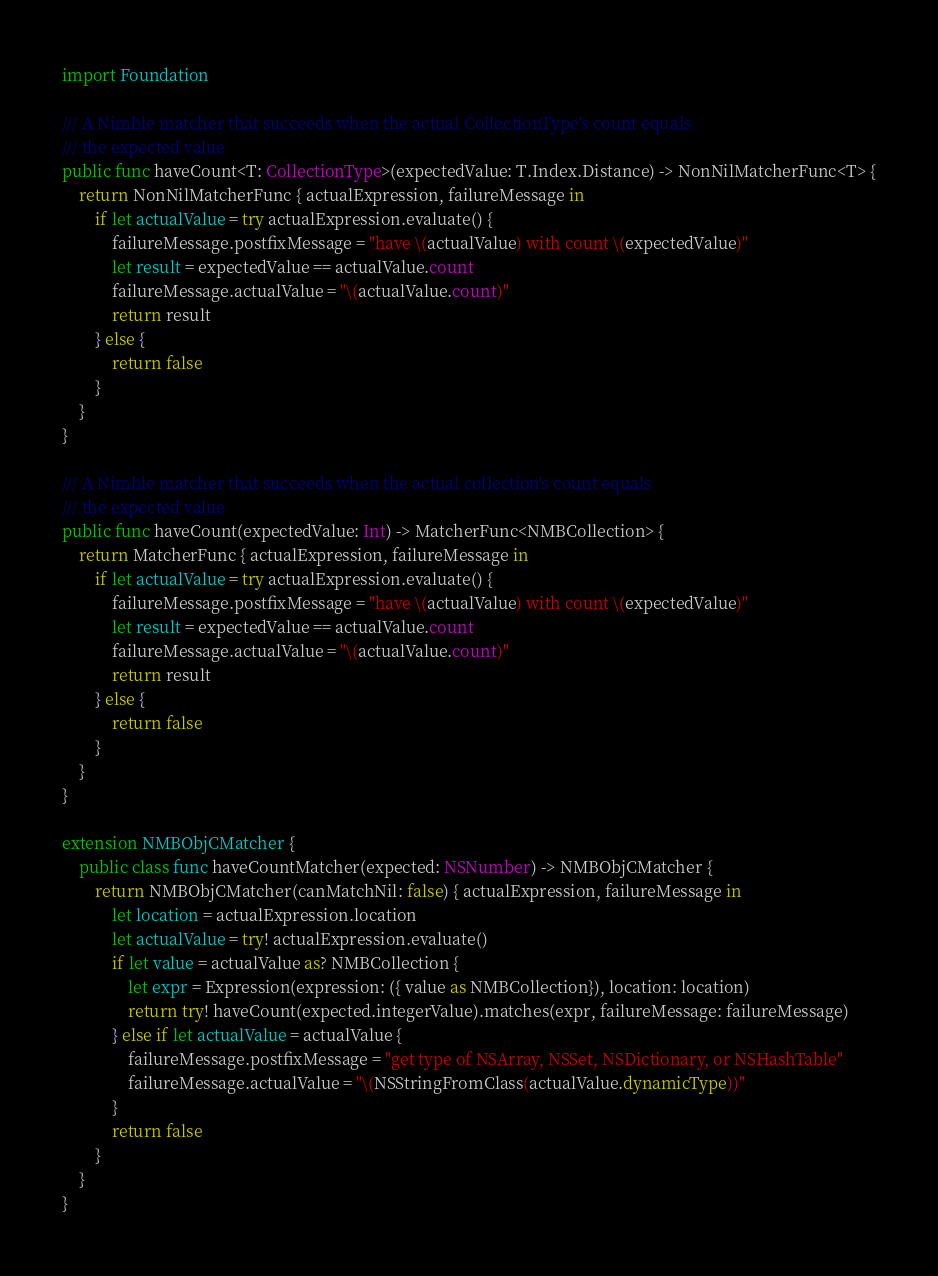Convert code to text. <code><loc_0><loc_0><loc_500><loc_500><_Swift_>import Foundation

/// A Nimble matcher that succeeds when the actual CollectionType's count equals
/// the expected value
public func haveCount<T: CollectionType>(expectedValue: T.Index.Distance) -> NonNilMatcherFunc<T> {
    return NonNilMatcherFunc { actualExpression, failureMessage in
        if let actualValue = try actualExpression.evaluate() {
            failureMessage.postfixMessage = "have \(actualValue) with count \(expectedValue)"
            let result = expectedValue == actualValue.count
            failureMessage.actualValue = "\(actualValue.count)"
            return result
        } else {
            return false
        }
    }
}

/// A Nimble matcher that succeeds when the actual collection's count equals
/// the expected value
public func haveCount(expectedValue: Int) -> MatcherFunc<NMBCollection> {
    return MatcherFunc { actualExpression, failureMessage in
        if let actualValue = try actualExpression.evaluate() {
            failureMessage.postfixMessage = "have \(actualValue) with count \(expectedValue)"
            let result = expectedValue == actualValue.count
            failureMessage.actualValue = "\(actualValue.count)"
            return result
        } else {
            return false
        }
    }
}

extension NMBObjCMatcher {
    public class func haveCountMatcher(expected: NSNumber) -> NMBObjCMatcher {
        return NMBObjCMatcher(canMatchNil: false) { actualExpression, failureMessage in
            let location = actualExpression.location
            let actualValue = try! actualExpression.evaluate()
            if let value = actualValue as? NMBCollection {
                let expr = Expression(expression: ({ value as NMBCollection}), location: location)
                return try! haveCount(expected.integerValue).matches(expr, failureMessage: failureMessage)
            } else if let actualValue = actualValue {
                failureMessage.postfixMessage = "get type of NSArray, NSSet, NSDictionary, or NSHashTable"
                failureMessage.actualValue = "\(NSStringFromClass(actualValue.dynamicType))"
            }
            return false
        }
    }
}
</code> 